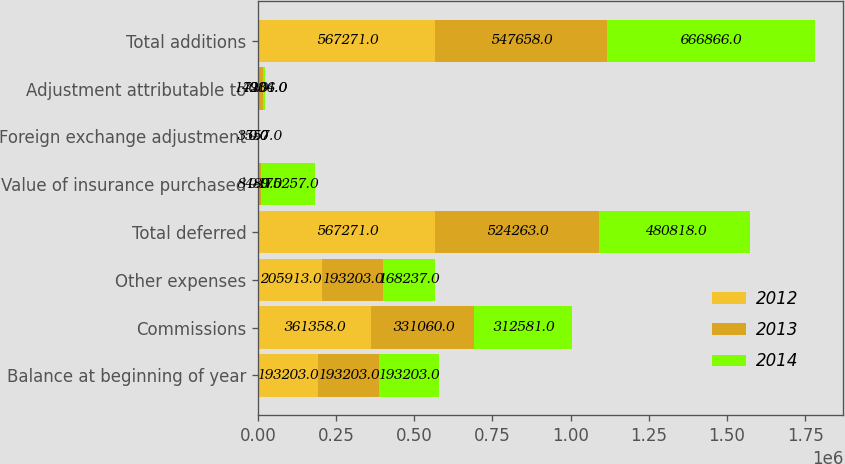Convert chart. <chart><loc_0><loc_0><loc_500><loc_500><stacked_bar_chart><ecel><fcel>Balance at beginning of year<fcel>Commissions<fcel>Other expenses<fcel>Total deferred<fcel>Value of insurance purchased<fcel>Foreign exchange adjustment<fcel>Adjustment attributable to<fcel>Total additions<nl><fcel>2012<fcel>193203<fcel>361358<fcel>205913<fcel>567271<fcel>0<fcel>0<fcel>0<fcel>567271<nl><fcel>2013<fcel>193203<fcel>331060<fcel>193203<fcel>524263<fcel>8489<fcel>0<fcel>14906<fcel>547658<nl><fcel>2014<fcel>193203<fcel>312581<fcel>168237<fcel>480818<fcel>175257<fcel>3557<fcel>7234<fcel>666866<nl></chart> 